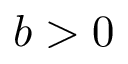<formula> <loc_0><loc_0><loc_500><loc_500>b > 0</formula> 